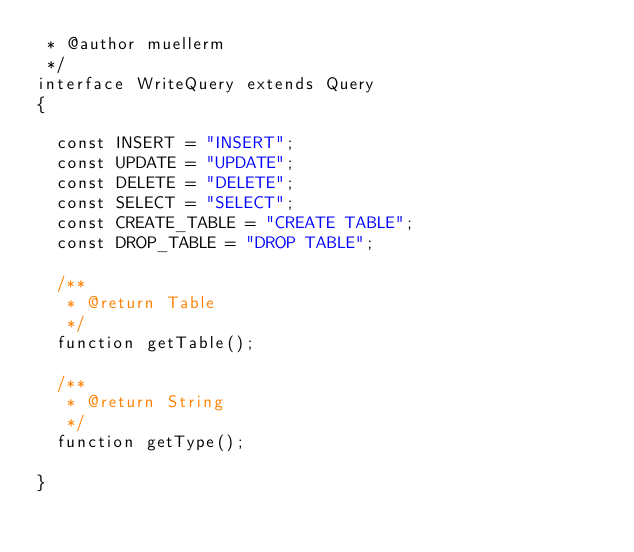<code> <loc_0><loc_0><loc_500><loc_500><_PHP_> * @author muellerm
 */
interface WriteQuery extends Query
{

  const INSERT = "INSERT";
  const UPDATE = "UPDATE";
  const DELETE = "DELETE";
  const SELECT = "SELECT";
  const CREATE_TABLE = "CREATE TABLE";
  const DROP_TABLE = "DROP TABLE";
  
  /**
   * @return Table
   */
  function getTable();
  
  /**
   * @return String
   */
  function getType();
  
}
</code> 